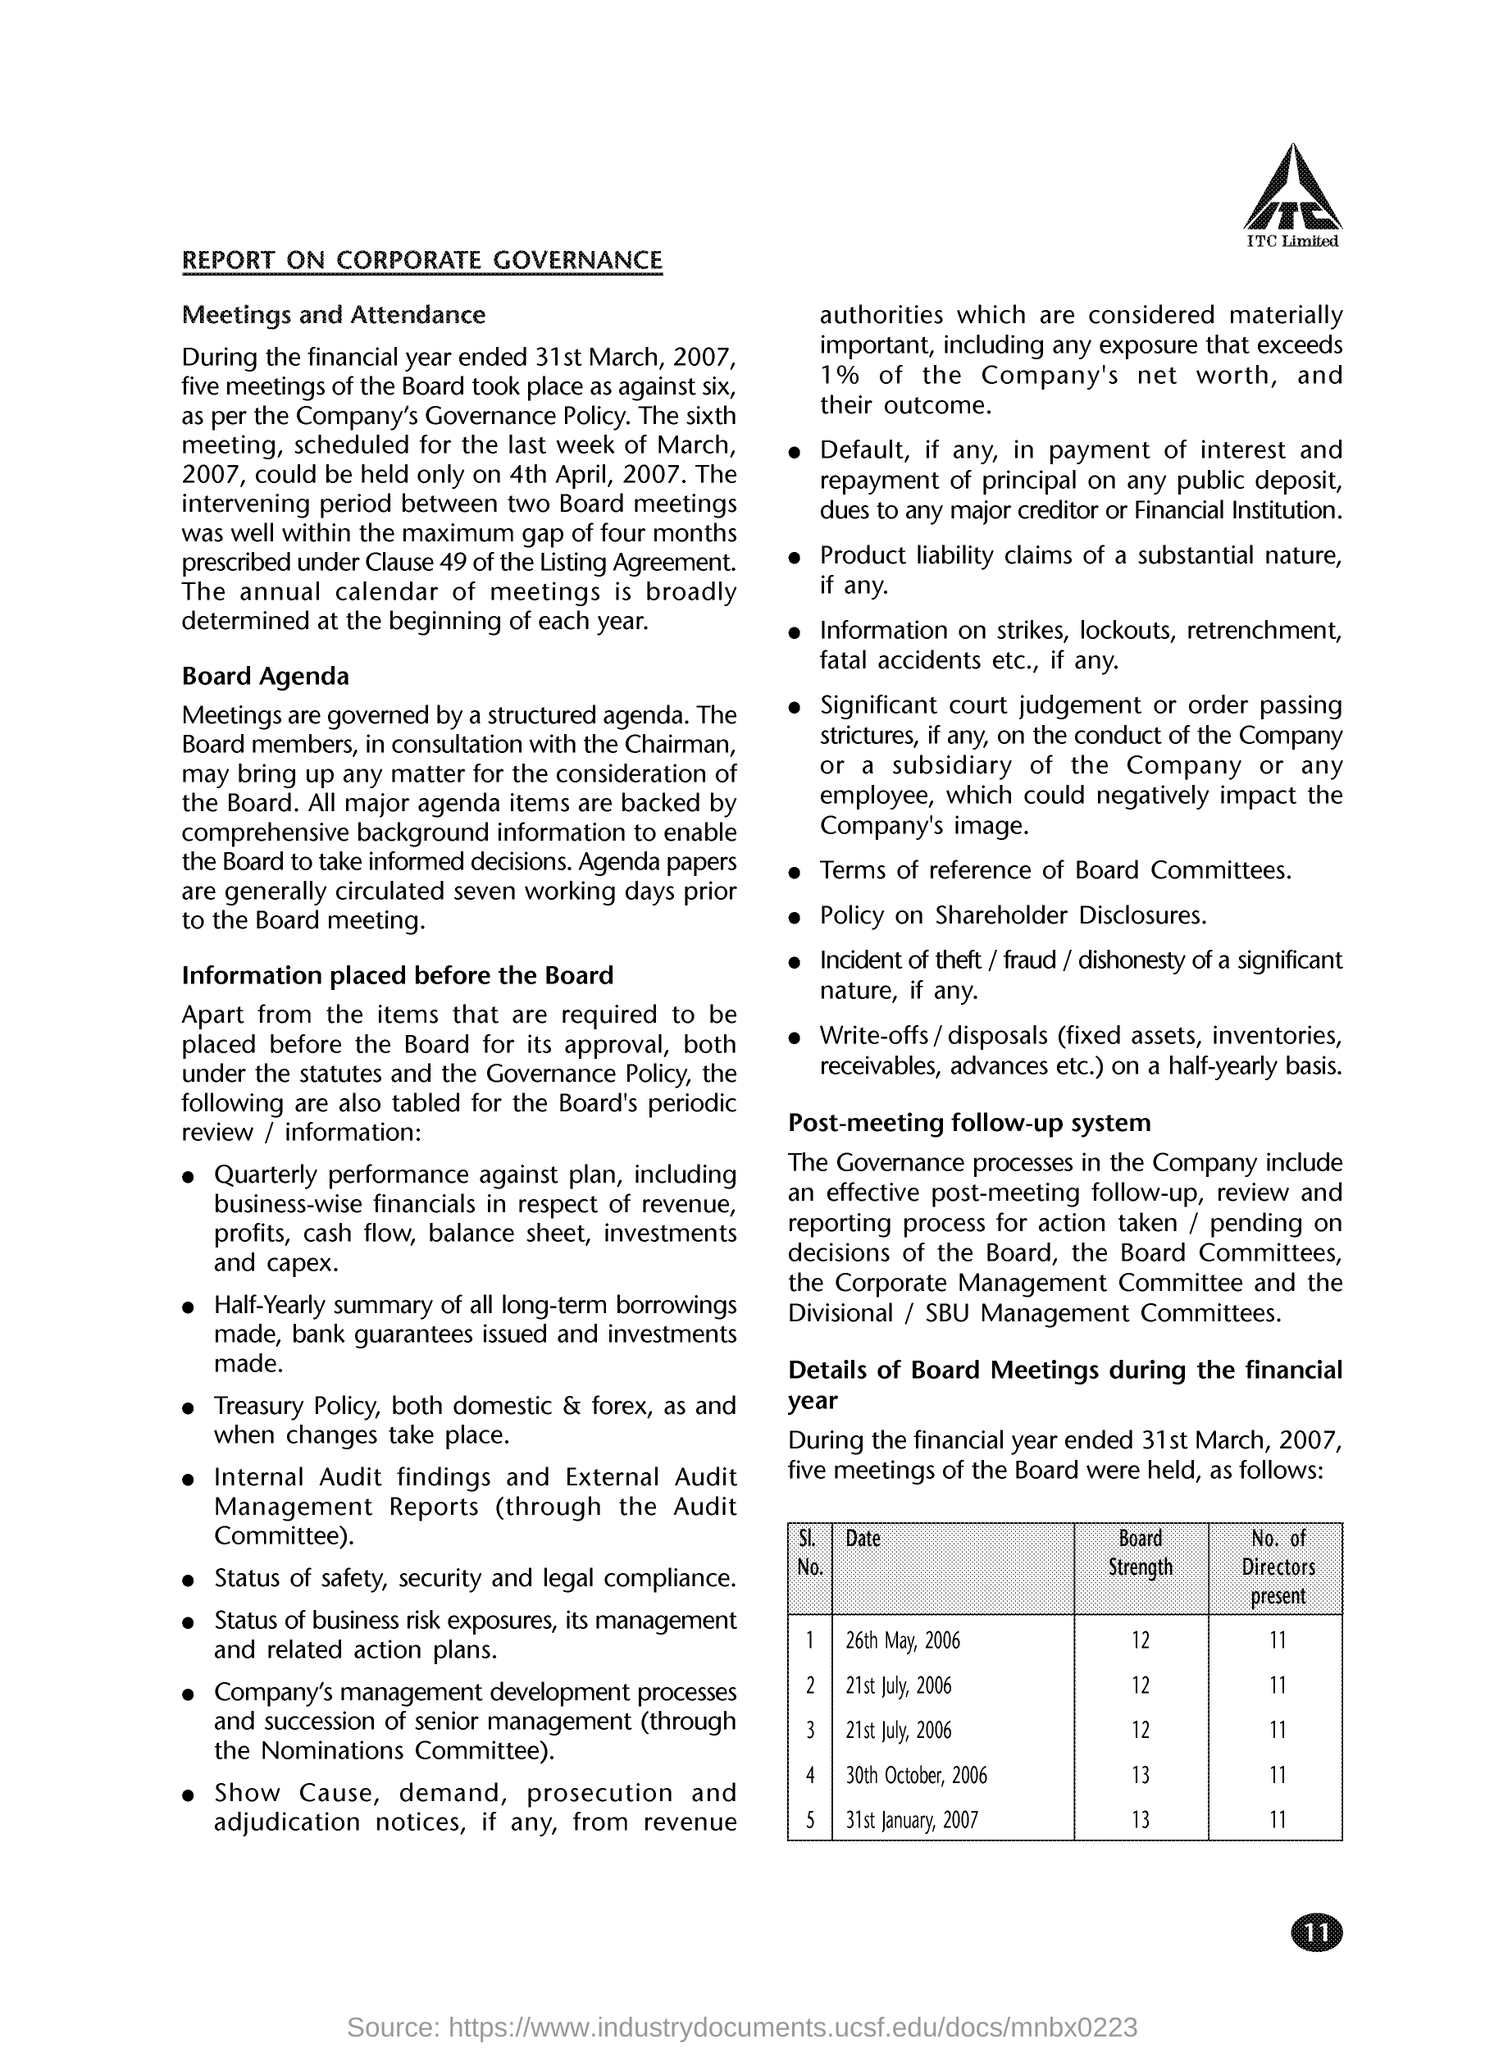What is the Board Strength for date 26th May, 2006?
Make the answer very short. 12. What is the Board Strength for date 21st July, 2006?
Your answer should be very brief. 12. What is the Board Strength for date 30th October, 2006?
Keep it short and to the point. 13. What is the Board Strength for date 31st January, 2007?
Make the answer very short. 13. What is the No. of Directors present for date 26th May, 2006?
Your answer should be compact. 11. What is the No. of Directors present for date  21st July, 2006?
Make the answer very short. 11. What is the No. of Directors present for date 30th October, 2006?
Give a very brief answer. 11. What is the No. of Directors present for date 31st January, 2007?
Provide a succinct answer. 11. 